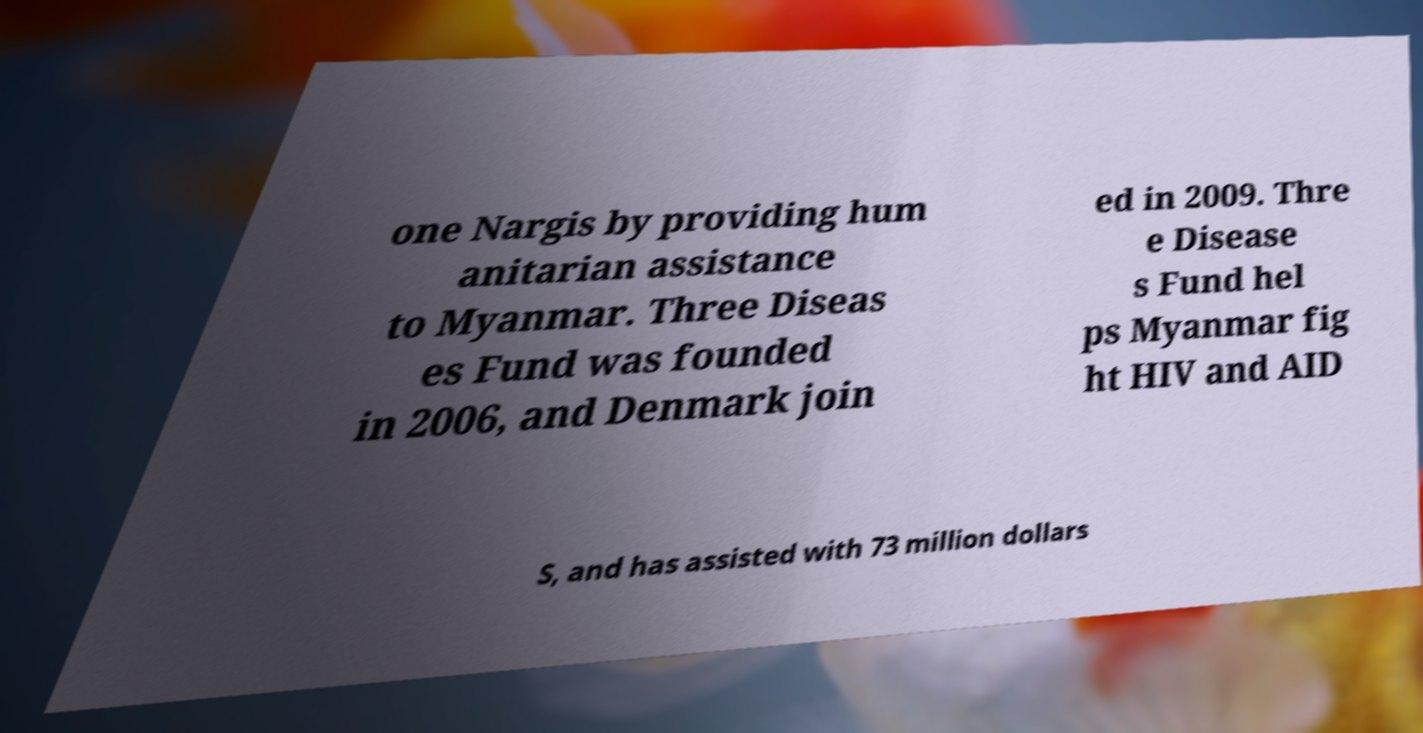There's text embedded in this image that I need extracted. Can you transcribe it verbatim? one Nargis by providing hum anitarian assistance to Myanmar. Three Diseas es Fund was founded in 2006, and Denmark join ed in 2009. Thre e Disease s Fund hel ps Myanmar fig ht HIV and AID S, and has assisted with 73 million dollars 